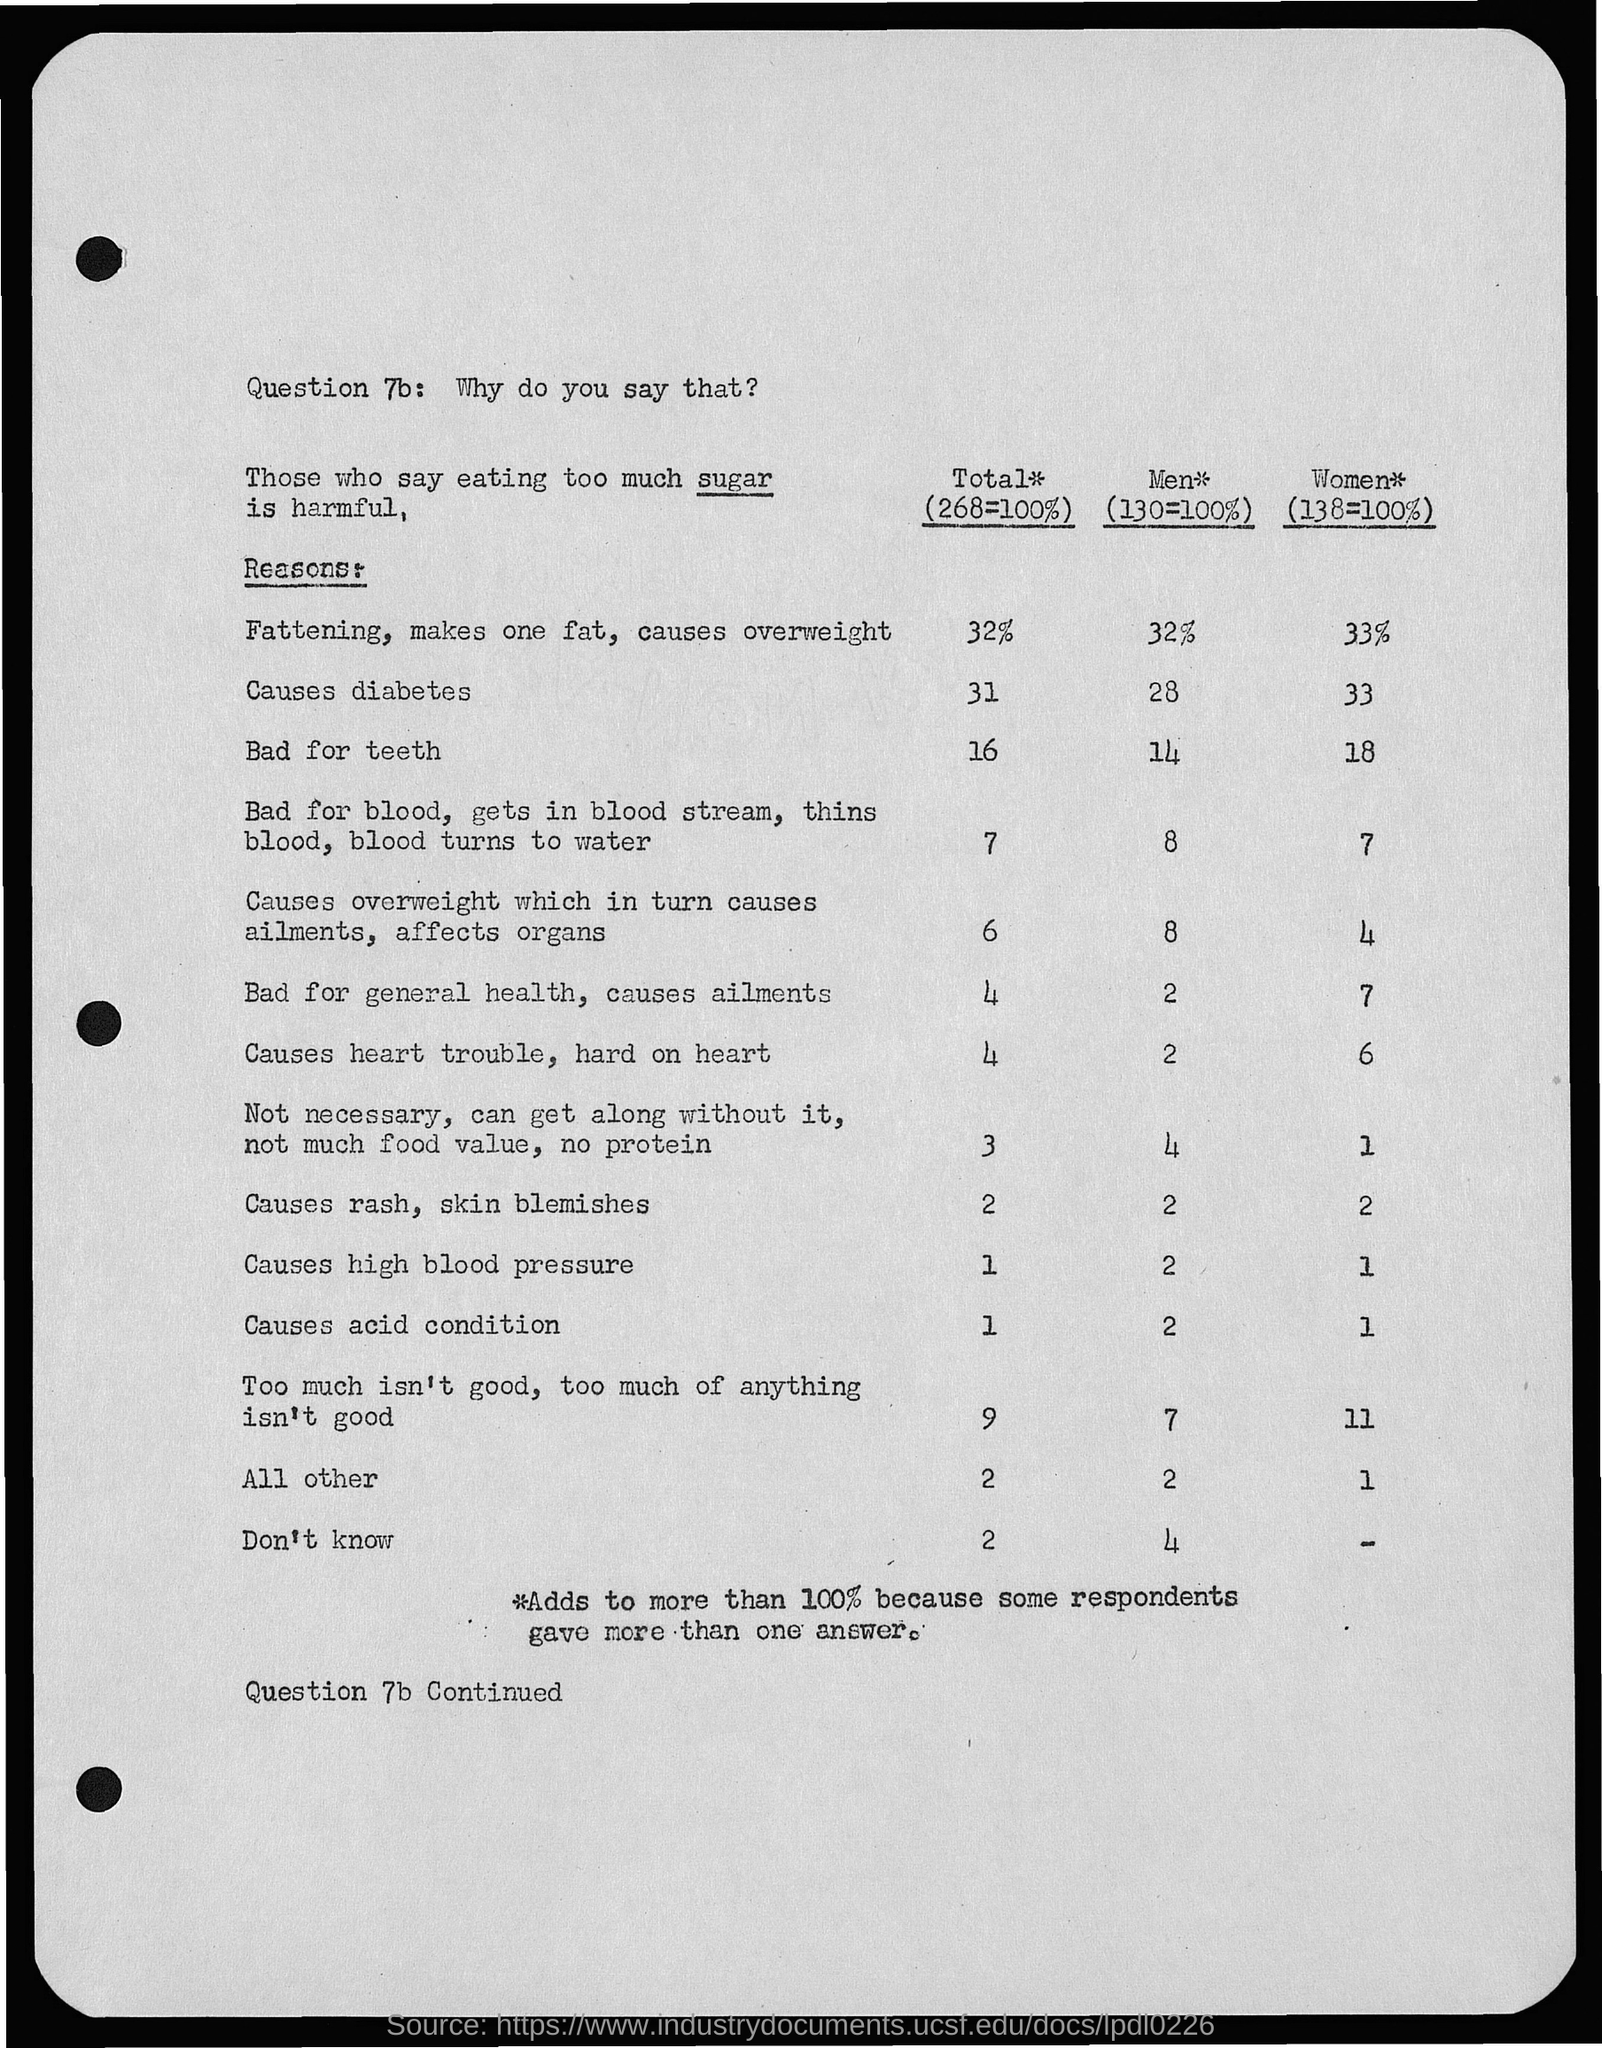What is question 7b: ?
Keep it short and to the point. Why do you say that?. 